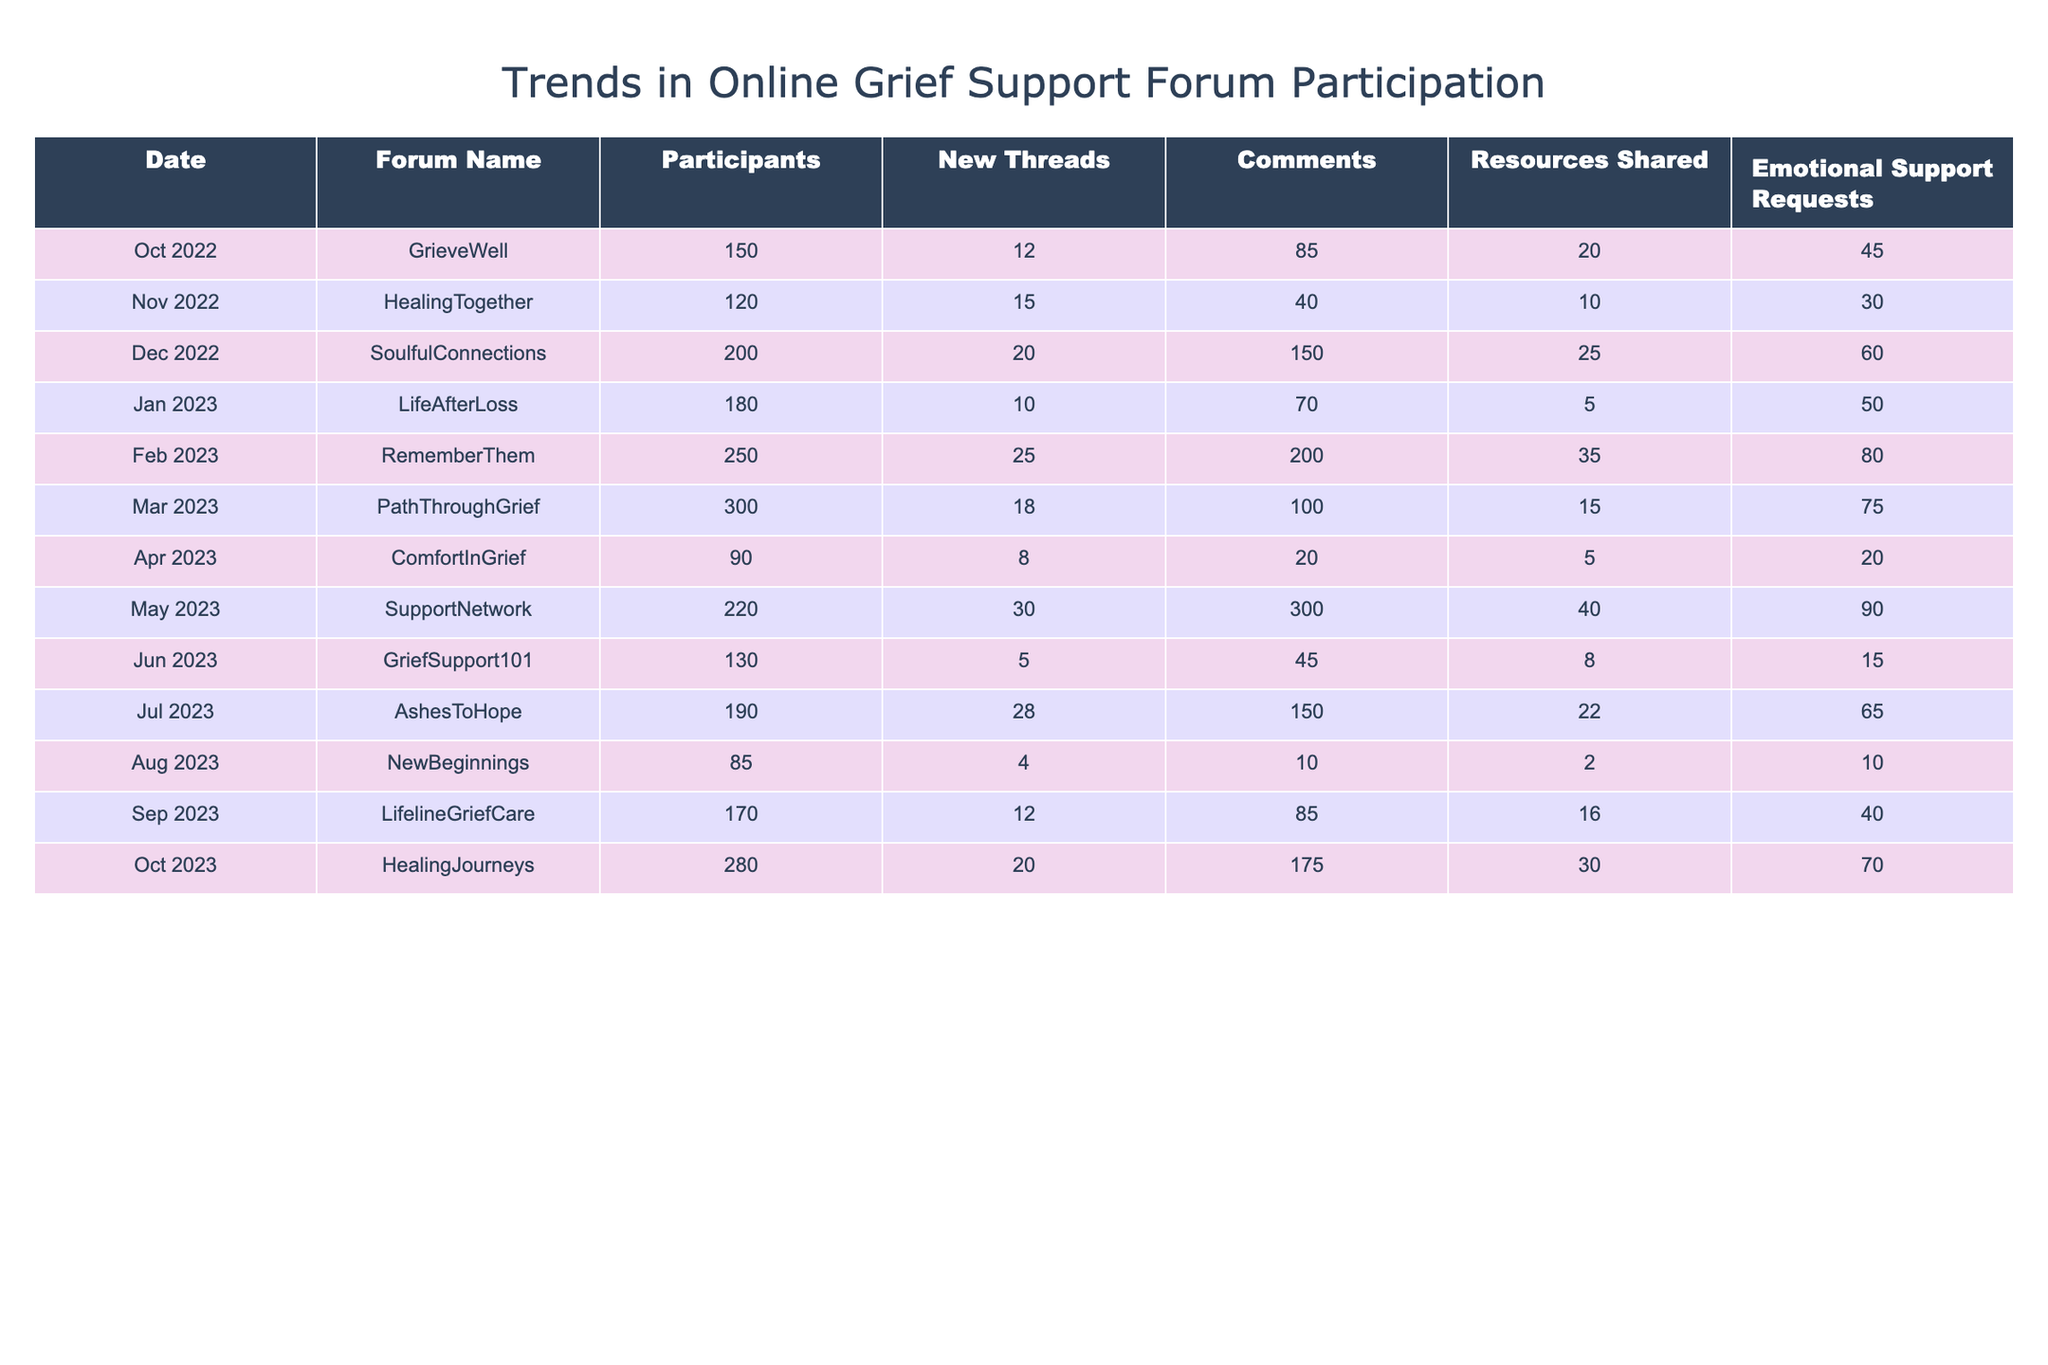What was the highest number of participants in a forum? The row with the highest number of participants is "PathThroughGrief" with 300 participants in March 2023.
Answer: 300 Which forum had the most emotional support requests in a month? The "SupportNetwork" forum had the highest emotional support requests with 90 in May 2023.
Answer: 90 What is the total number of comments across all forums for the year? Adding the comments from each month: (85 + 40 + 150 + 70 + 200 + 100 + 20 + 300 + 45 + 150 + 85 + 175) gives a total of 1,570 comments.
Answer: 1570 Did "HealingTogether" have more participants than "ComfortInGrief"? "HealingTogether" had 120 participants, while "ComfortInGrief" had 90 participants, so yes, it had more participants.
Answer: Yes What was the average number of new threads created per month? The new threads are: (12 + 15 + 20 + 10 + 25 + 18 + 8 + 30 + 5 + 28 + 4 + 20) which totals  5 + 4 + 28 + 20 + 12 + 15 + 20 + 10 + 25 + 18 + 8 + 30 which is 6 + 4 + 2 + 0 + 0 + 0 + 30 + 3. This gives a total of 200 used in 12 months, hence the average is 200/12, approximately 16.67.
Answer: Approximately 16.67 What is the difference in emotional support requests between the months of February and April? "RememberThem" in February had 80 emotional support requests and "ComfortInGrief" in April had 20 requests, so the difference is 80 - 20 = 60.
Answer: 60 Which month saw the largest increase in participants compared to the previous month? Comparing month-to-month participant counts, from February to March there was a change from 250 to 300. Therefore, the increase is 300 - 250 = 50, which is the largest increase.
Answer: 50 How many resources were shared in total across all forums? Summing the resources shared: (20 + 10 + 25 + 5 + 35 + 15 + 5 + 40 + 8 + 22 + 2 + 30) gives a total of 292 resources.
Answer: 292 Which forum had the least number of new threads? The forum with the least new threads is "GriefSupport101" which had only 5 new threads in June.
Answer: 5 Is there a month where the number of participants was lower than 100? Yes, in August 2023, the number of participants was 85, which is lower than 100.
Answer: Yes What was the overall trend in participants from October 2022 to October 2023? The number of participants increased from 150 in October 2022 to 280 in October 2023. This shows an upward trend over the year.
Answer: Upward trend 